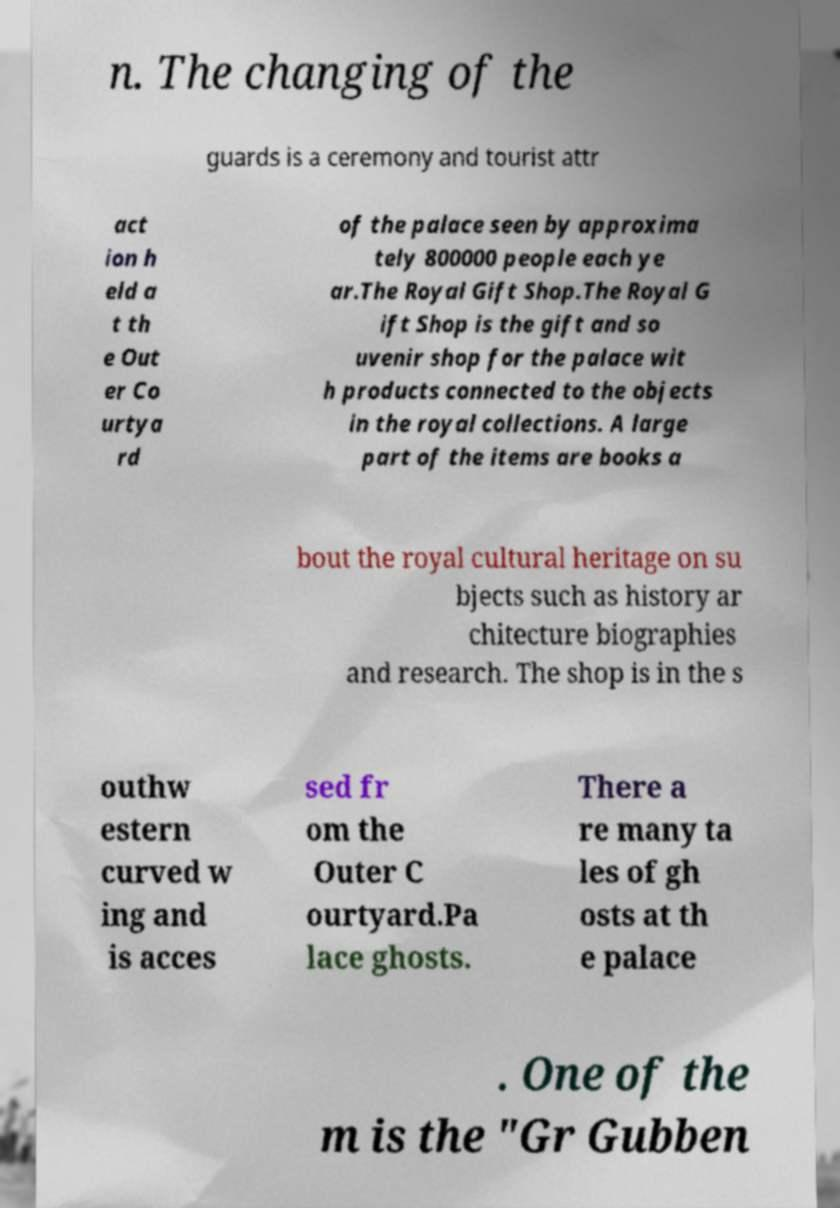What messages or text are displayed in this image? I need them in a readable, typed format. n. The changing of the guards is a ceremony and tourist attr act ion h eld a t th e Out er Co urtya rd of the palace seen by approxima tely 800000 people each ye ar.The Royal Gift Shop.The Royal G ift Shop is the gift and so uvenir shop for the palace wit h products connected to the objects in the royal collections. A large part of the items are books a bout the royal cultural heritage on su bjects such as history ar chitecture biographies and research. The shop is in the s outhw estern curved w ing and is acces sed fr om the Outer C ourtyard.Pa lace ghosts. There a re many ta les of gh osts at th e palace . One of the m is the "Gr Gubben 